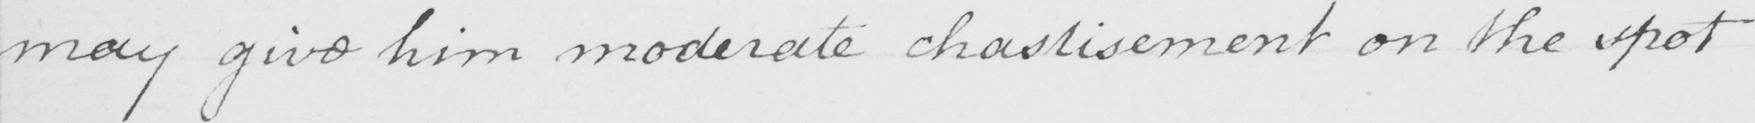What text is written in this handwritten line? may give him moderate chastisement on the spot 